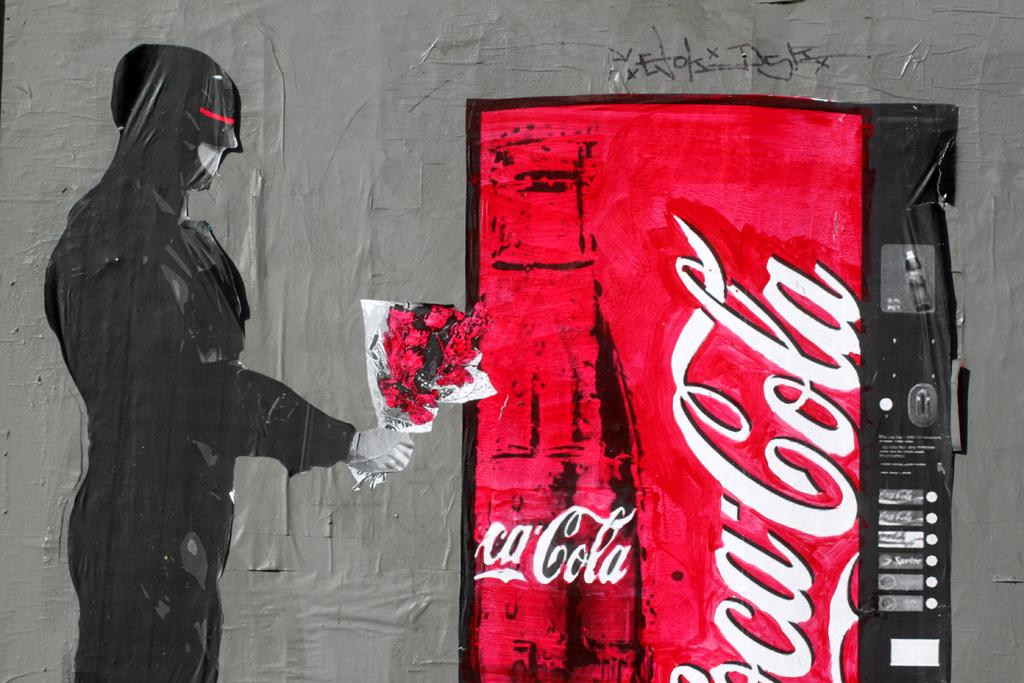What is on the wall in the image? There is a poster on the wall in the image. What can be seen on the poster? There is text written on the poster, and flowers are depicted on it. What is the person in the poster doing? The person depicted on the poster is holding a bouquet. What type of insect can be seen crawling on the text of the poster? There is no insect present on the poster in the image. 